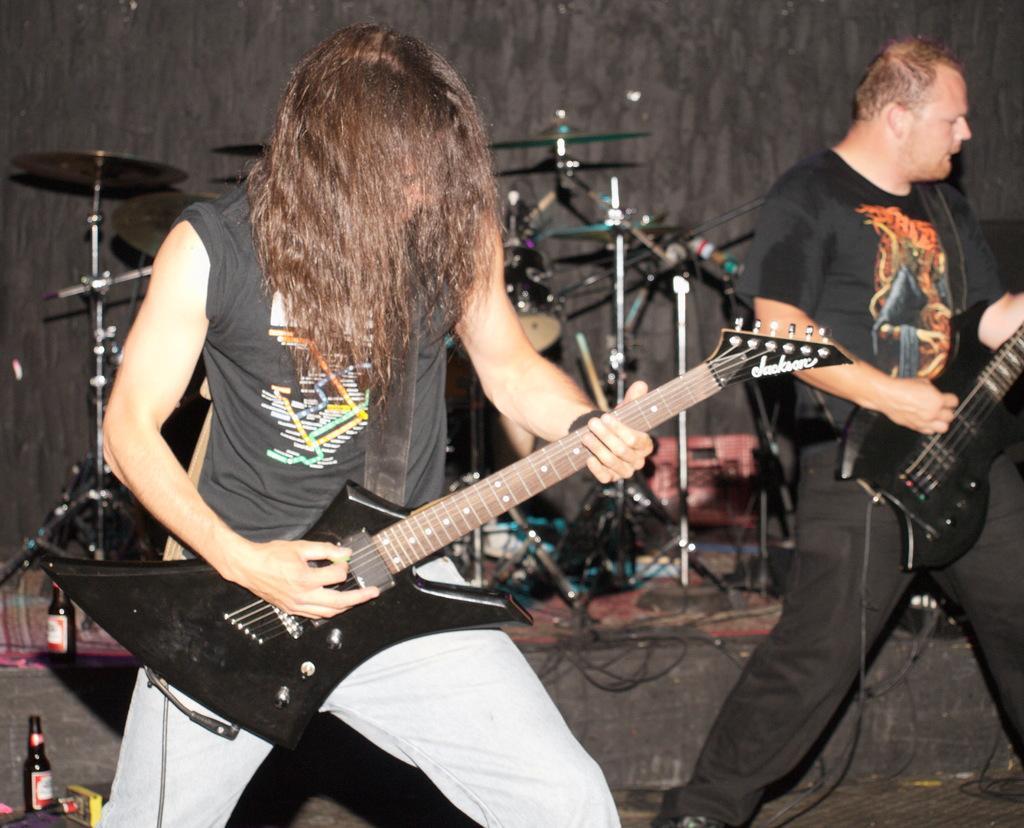Describe this image in one or two sentences. In this image there are two persons who are the guitar with their hands. At the background there are musical instruments like drums and musical plates. At the bottom there is a glass bottle. 